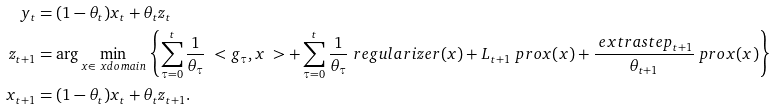<formula> <loc_0><loc_0><loc_500><loc_500>y _ { t } & = ( 1 - \theta _ { t } ) x _ { t } + \theta _ { t } z _ { t } \\ z _ { t + 1 } & = \arg \min _ { x \in \ x d o m a i n } \left \{ \sum _ { \tau = 0 } ^ { t } \frac { 1 } { \theta _ { \tau } } \ < g _ { \tau } , x \ > + \sum _ { \tau = 0 } ^ { t } \frac { 1 } { \theta _ { \tau } } \ r e g u l a r i z e r ( x ) + L _ { t + 1 } \ p r o x ( x ) + \frac { \ e x t r a s t e p _ { t + 1 } } { \theta _ { t + 1 } } \ p r o x ( x ) \right \} \\ x _ { t + 1 } & = ( 1 - \theta _ { t } ) x _ { t } + \theta _ { t } z _ { t + 1 } .</formula> 